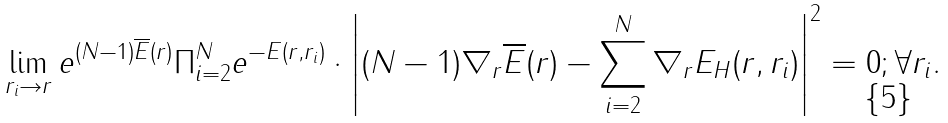<formula> <loc_0><loc_0><loc_500><loc_500>\lim _ { { r } _ { i } \to { r } } e ^ { ( N - 1 ) { \overline { E } } ( { r } ) } \Pi _ { i = 2 } ^ { N } e ^ { - E ( { r } , { r } _ { i } ) } \cdot \left | ( N - 1 ) \nabla _ { r } { \overline { E } } ( { r } ) - \sum _ { i = 2 } ^ { N } \nabla _ { r } E _ { H } ( { r } , { r } _ { i } ) \right | ^ { 2 } = 0 ; \forall { r } _ { i } .</formula> 